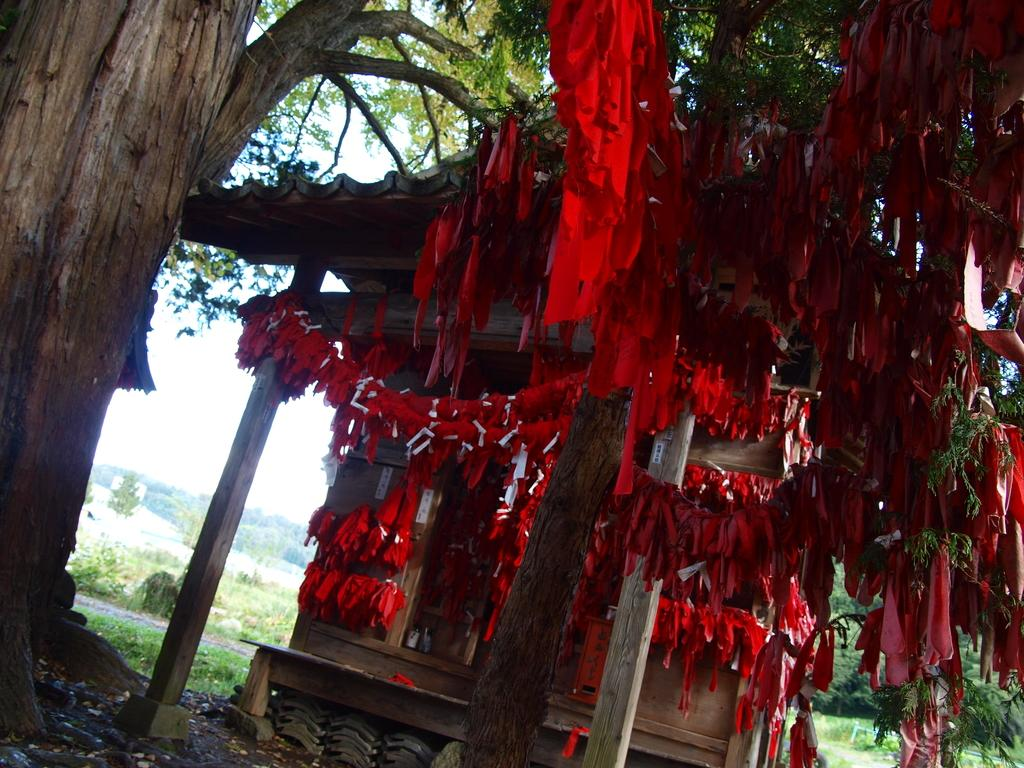What is the main object in the foreground of the image? There is a tree in the image, and clothes are tied to it. What other structures can be seen in the image? There are poles and a small shed in the image. What can be seen in the background of the image? There are trees, plants, and objects in the background of the image, as well as the sky. What type of wool is being used to create the map in the image? There is no map or wool present in the image. How does the wealth of the people in the image compare to the wealth of people in a different image? There is no information about wealth or any other image provided, so it cannot be compared. 